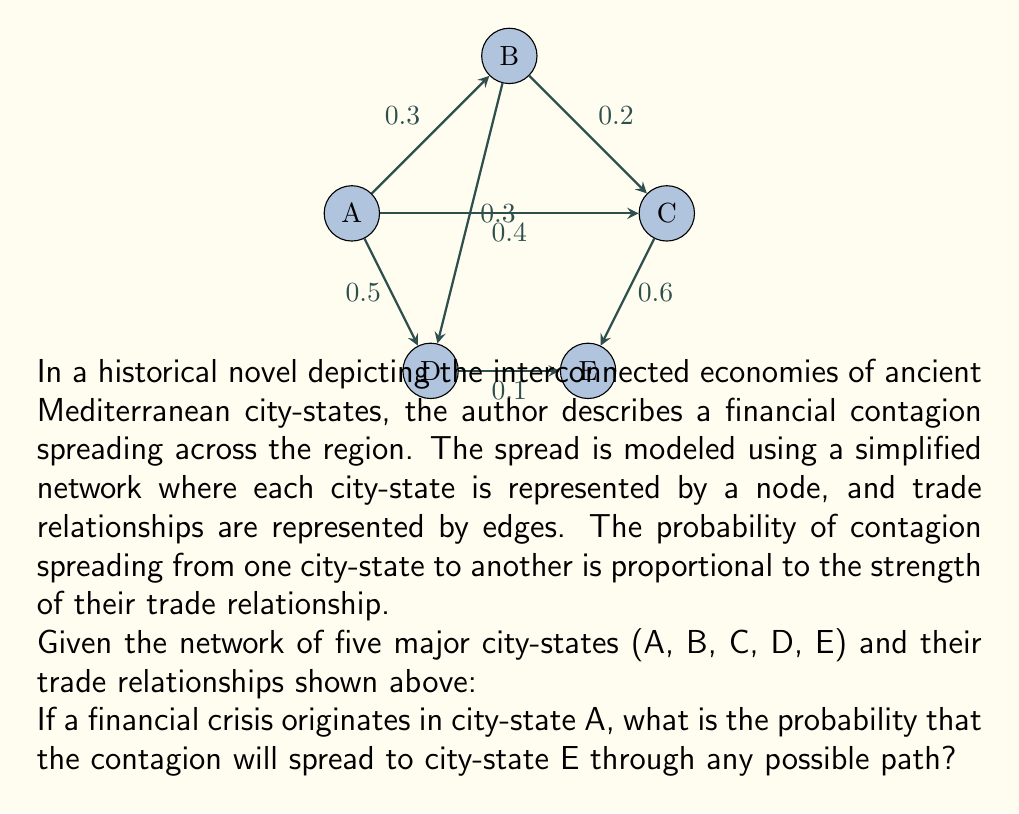Help me with this question. To solve this problem, we need to consider all possible paths from A to E and calculate the probability of contagion spreading through each path. Then, we'll combine these probabilities to get the total probability of contagion reaching E.

Step 1: Identify all possible paths from A to E
1. A → C → E
2. A → D → E
3. A → B → C → E
4. A → B → D → E

Step 2: Calculate the probability for each path
1. P(A → C → E) = 0.4 × 0.6 = 0.24
2. P(A → D → E) = 0.5 × 0.1 = 0.05
3. P(A → B → C → E) = 0.3 × 0.2 × 0.6 = 0.036
4. P(A → B → D → E) = 0.3 × 0.3 × 0.1 = 0.009

Step 3: Calculate the probability that the contagion does NOT spread through each path
1. P(not A → C → E) = 1 - 0.24 = 0.76
2. P(not A → D → E) = 1 - 0.05 = 0.95
3. P(not A → B → C → E) = 1 - 0.036 = 0.964
4. P(not A → B → D → E) = 1 - 0.009 = 0.991

Step 4: Calculate the probability that the contagion does NOT spread through any path
P(no contagion) = 0.76 × 0.95 × 0.964 × 0.991 = 0.6911

Step 5: Calculate the probability that the contagion DOES spread through at least one path
P(contagion reaches E) = 1 - P(no contagion) = 1 - 0.6911 = 0.3089

Therefore, the probability that the financial contagion will spread from city-state A to city-state E through any possible path is approximately 0.3089 or 30.89%.
Answer: 0.3089 